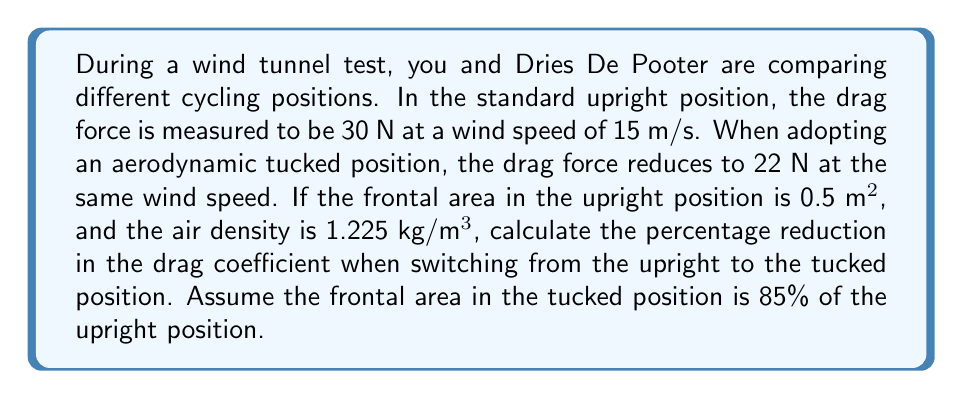Teach me how to tackle this problem. To solve this problem, we'll use the drag equation and compare the drag coefficients for both positions. The drag equation is:

$$F_D = \frac{1}{2} \rho v^2 C_D A$$

Where:
$F_D$ = drag force (N)
$\rho$ = air density (kg/m³)
$v$ = velocity (m/s)
$C_D$ = drag coefficient
$A$ = frontal area (m²)

1. Calculate $C_D$ for the upright position:
   $$30 = \frac{1}{2} \cdot 1.225 \cdot 15^2 \cdot C_{D1} \cdot 0.5$$
   $$C_{D1} = \frac{30}{\frac{1}{2} \cdot 1.225 \cdot 15^2 \cdot 0.5} \approx 0.4369$$

2. Calculate $C_D$ for the tucked position:
   Frontal area in tucked position = $0.5 \cdot 0.85 = 0.425$ m²
   $$22 = \frac{1}{2} \cdot 1.225 \cdot 15^2 \cdot C_{D2} \cdot 0.425$$
   $$C_{D2} = \frac{22}{\frac{1}{2} \cdot 1.225 \cdot 15^2 \cdot 0.425} \approx 0.3804$$

3. Calculate the percentage reduction:
   $$\text{Reduction} = \frac{C_{D1} - C_{D2}}{C_{D1}} \cdot 100\%$$
   $$= \frac{0.4369 - 0.3804}{0.4369} \cdot 100\% \approx 12.93\%$$
Answer: The percentage reduction in the drag coefficient when switching from the upright to the tucked position is approximately 12.93%. 